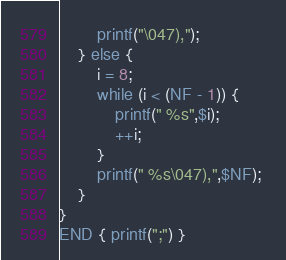Convert code to text. <code><loc_0><loc_0><loc_500><loc_500><_Awk_>        printf("\047),"); 
    } else {
        i = 8; 
        while (i < (NF - 1)) { 
            printf(" %s",$i); 
            ++i;
        }
        printf(" %s\047),",$NF); 
    }
}
END { printf(";") }</code> 